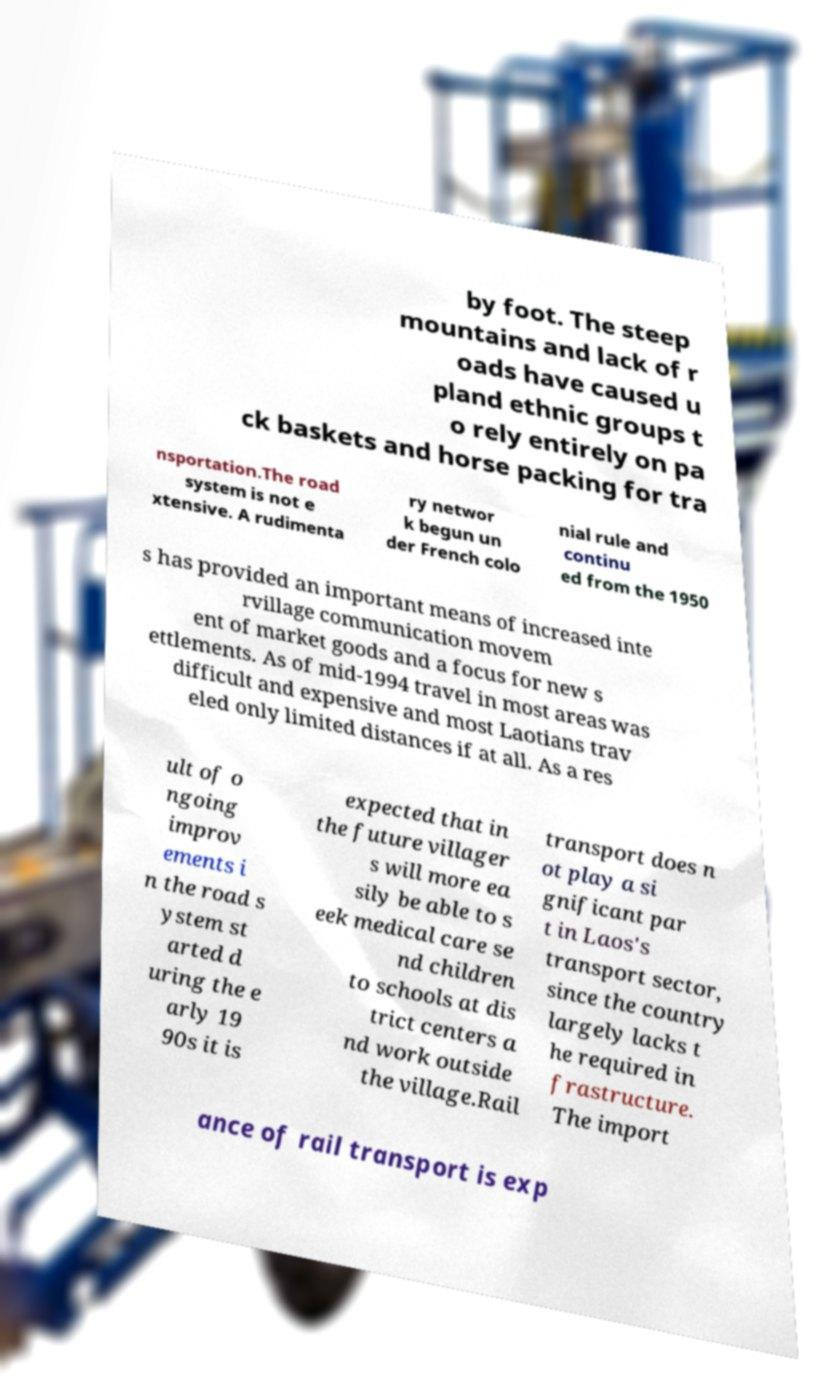Please read and relay the text visible in this image. What does it say? by foot. The steep mountains and lack of r oads have caused u pland ethnic groups t o rely entirely on pa ck baskets and horse packing for tra nsportation.The road system is not e xtensive. A rudimenta ry networ k begun un der French colo nial rule and continu ed from the 1950 s has provided an important means of increased inte rvillage communication movem ent of market goods and a focus for new s ettlements. As of mid-1994 travel in most areas was difficult and expensive and most Laotians trav eled only limited distances if at all. As a res ult of o ngoing improv ements i n the road s ystem st arted d uring the e arly 19 90s it is expected that in the future villager s will more ea sily be able to s eek medical care se nd children to schools at dis trict centers a nd work outside the village.Rail transport does n ot play a si gnificant par t in Laos's transport sector, since the country largely lacks t he required in frastructure. The import ance of rail transport is exp 